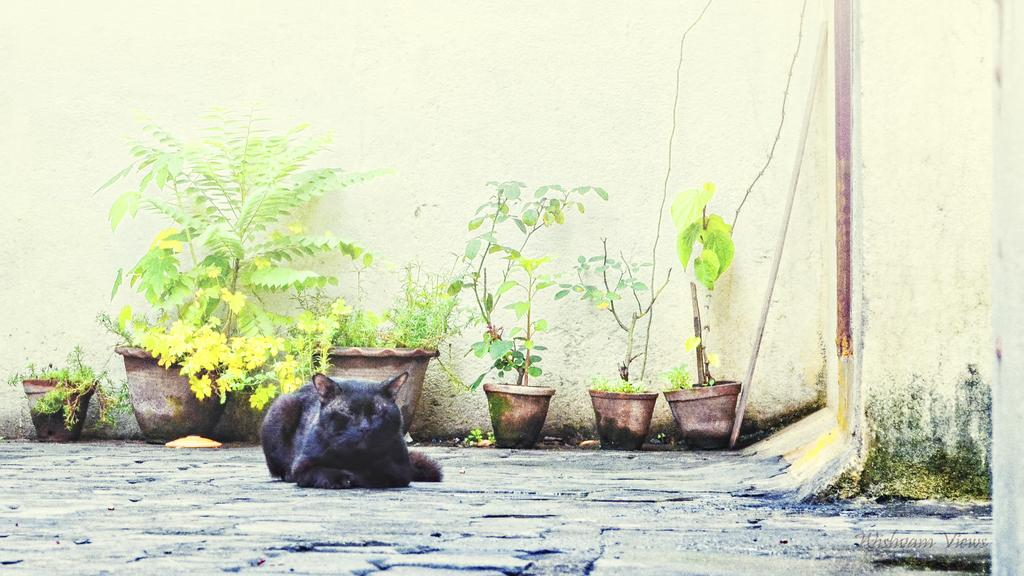What type of living organisms can be seen in the image? Plants can be seen in the image. What is the background element in the image? There is a wall in the image. What animal is present in the image? There is a cat in the image. How many pizzas are being served on the property in the image? There are no pizzas or properties present in the image; it features plants, a wall, and a cat. What adjustment can be made to the cat's position in the image? There is no need to adjust the cat's position in the image, as it is a static photograph. 